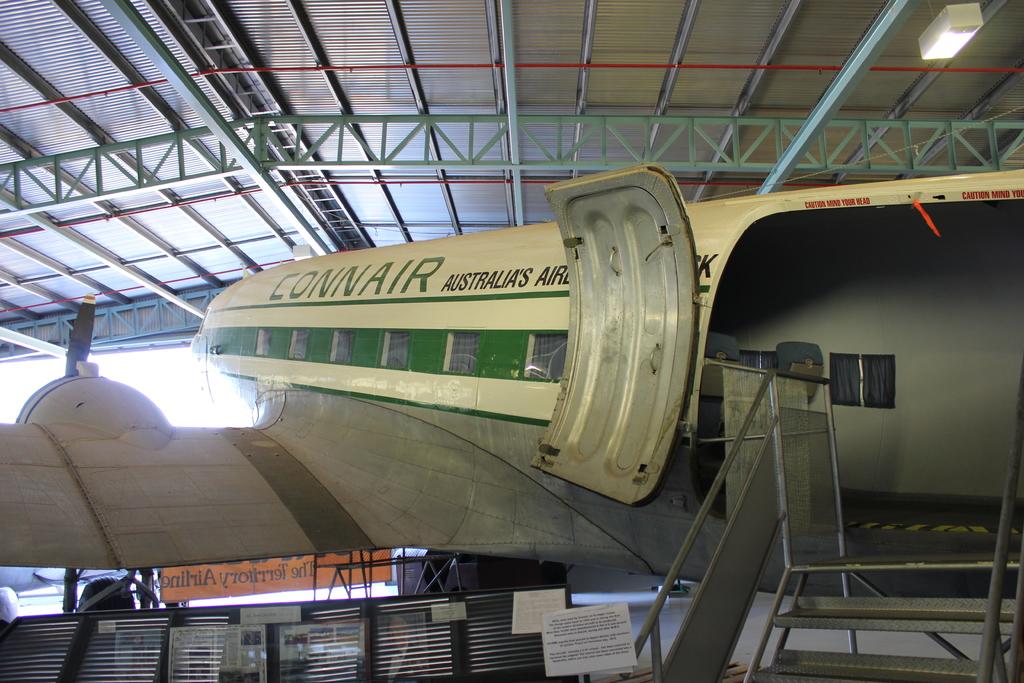What is the name of the airline?
Offer a very short reply. Connair. What is written in in red above the door?
Provide a succinct answer. Caution mind your head. 